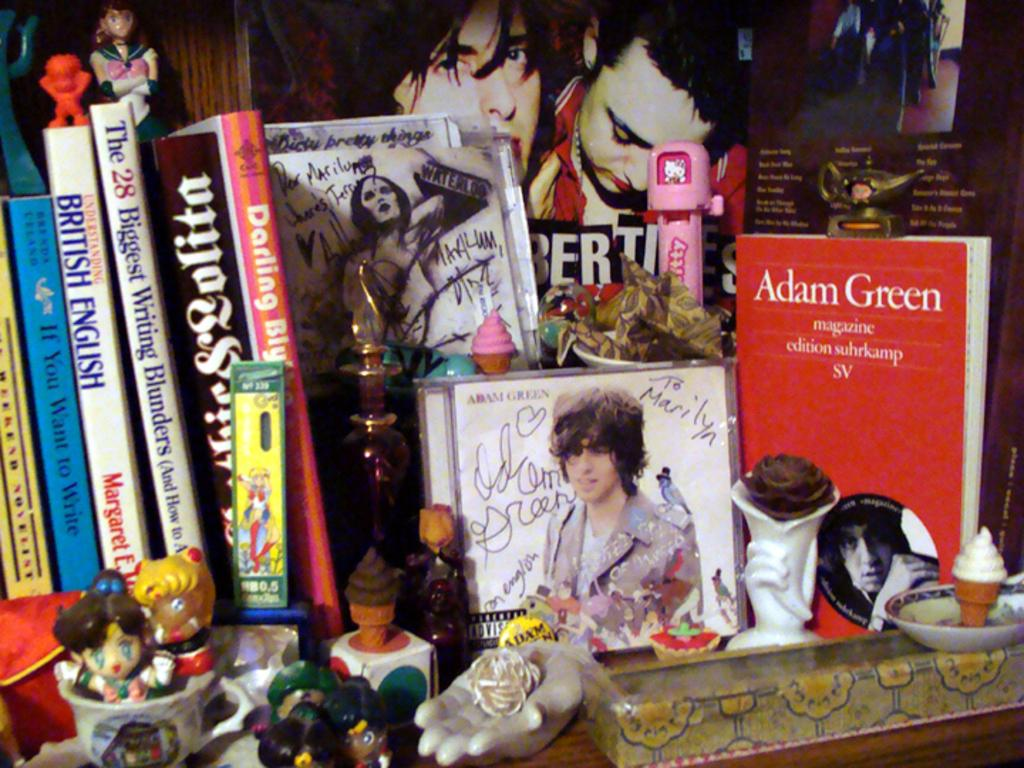<image>
Relay a brief, clear account of the picture shown. Desk with a red book that says "Adam Green"  on it. 